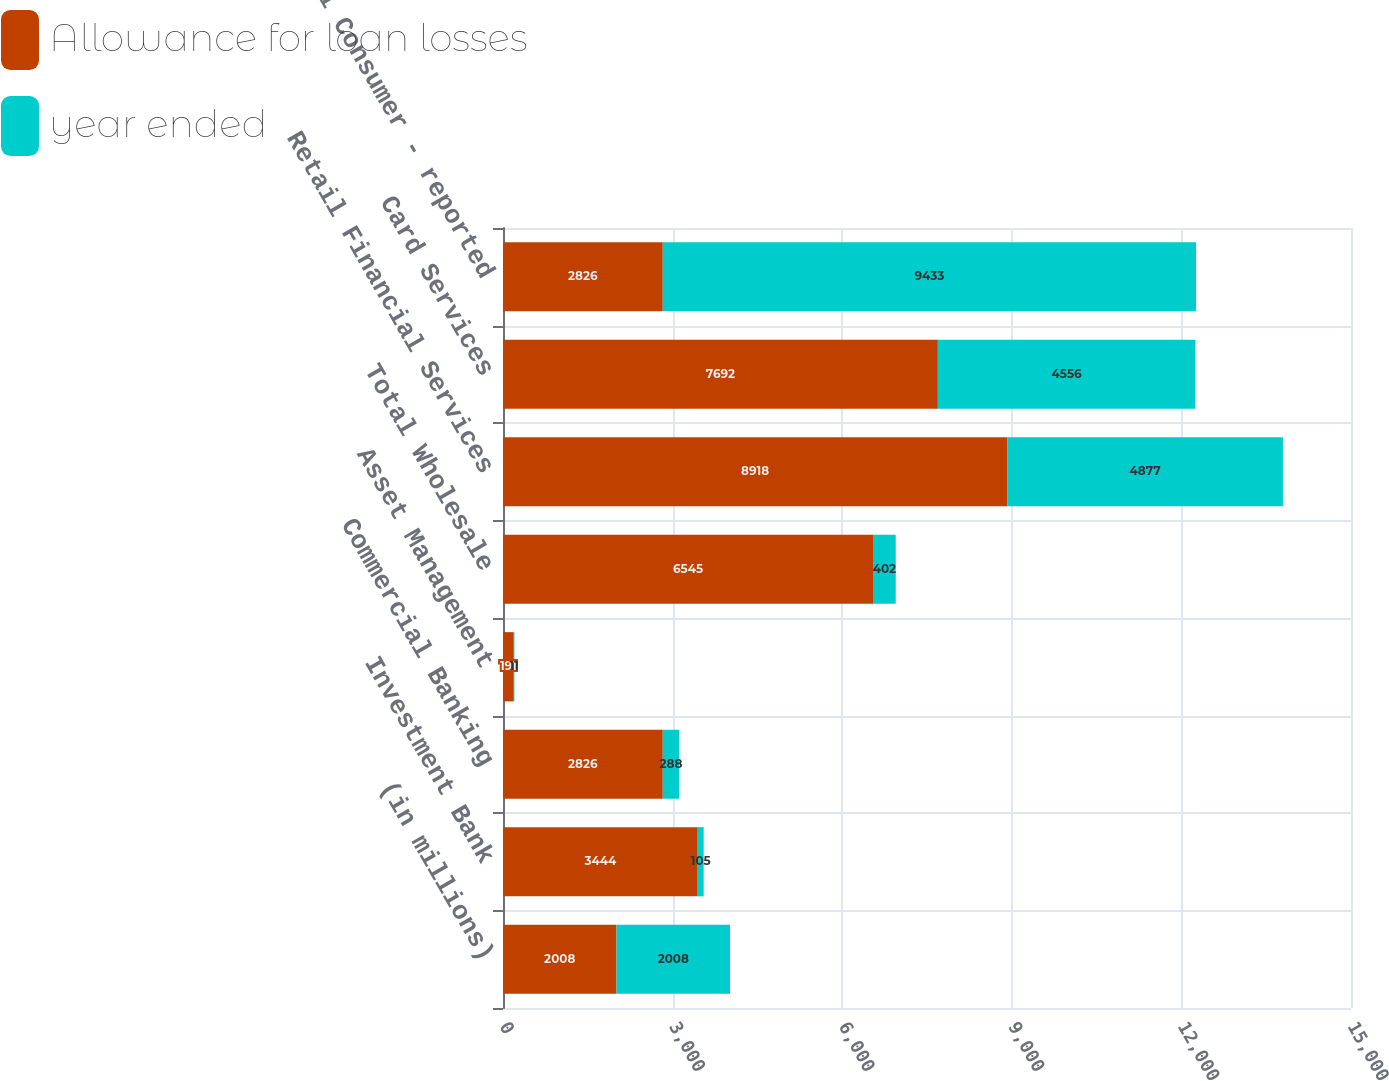Convert chart. <chart><loc_0><loc_0><loc_500><loc_500><stacked_bar_chart><ecel><fcel>(in millions)<fcel>Investment Bank<fcel>Commercial Banking<fcel>Asset Management<fcel>Total Wholesale<fcel>Retail Financial Services<fcel>Card Services<fcel>Total Consumer - reported<nl><fcel>Allowance for loan losses<fcel>2008<fcel>3444<fcel>2826<fcel>191<fcel>6545<fcel>8918<fcel>7692<fcel>2826<nl><fcel>year ended<fcel>2008<fcel>105<fcel>288<fcel>11<fcel>402<fcel>4877<fcel>4556<fcel>9433<nl></chart> 